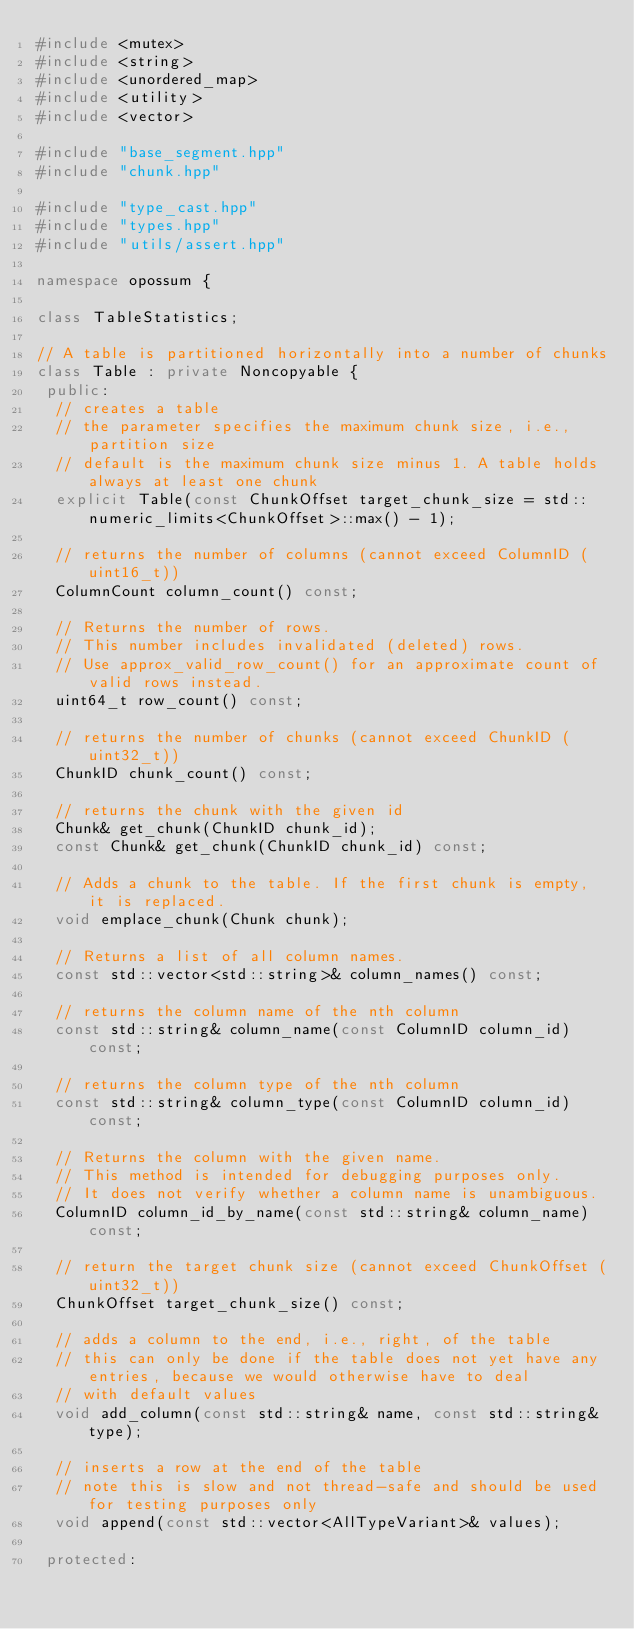Convert code to text. <code><loc_0><loc_0><loc_500><loc_500><_C++_>#include <mutex>
#include <string>
#include <unordered_map>
#include <utility>
#include <vector>

#include "base_segment.hpp"
#include "chunk.hpp"

#include "type_cast.hpp"
#include "types.hpp"
#include "utils/assert.hpp"

namespace opossum {

class TableStatistics;

// A table is partitioned horizontally into a number of chunks
class Table : private Noncopyable {
 public:
  // creates a table
  // the parameter specifies the maximum chunk size, i.e., partition size
  // default is the maximum chunk size minus 1. A table holds always at least one chunk
  explicit Table(const ChunkOffset target_chunk_size = std::numeric_limits<ChunkOffset>::max() - 1);

  // returns the number of columns (cannot exceed ColumnID (uint16_t))
  ColumnCount column_count() const;

  // Returns the number of rows.
  // This number includes invalidated (deleted) rows.
  // Use approx_valid_row_count() for an approximate count of valid rows instead.
  uint64_t row_count() const;

  // returns the number of chunks (cannot exceed ChunkID (uint32_t))
  ChunkID chunk_count() const;

  // returns the chunk with the given id
  Chunk& get_chunk(ChunkID chunk_id);
  const Chunk& get_chunk(ChunkID chunk_id) const;

  // Adds a chunk to the table. If the first chunk is empty, it is replaced.
  void emplace_chunk(Chunk chunk);

  // Returns a list of all column names.
  const std::vector<std::string>& column_names() const;

  // returns the column name of the nth column
  const std::string& column_name(const ColumnID column_id) const;

  // returns the column type of the nth column
  const std::string& column_type(const ColumnID column_id) const;

  // Returns the column with the given name.
  // This method is intended for debugging purposes only.
  // It does not verify whether a column name is unambiguous.
  ColumnID column_id_by_name(const std::string& column_name) const;

  // return the target chunk size (cannot exceed ChunkOffset (uint32_t))
  ChunkOffset target_chunk_size() const;

  // adds a column to the end, i.e., right, of the table
  // this can only be done if the table does not yet have any entries, because we would otherwise have to deal
  // with default values
  void add_column(const std::string& name, const std::string& type);

  // inserts a row at the end of the table
  // note this is slow and not thread-safe and should be used for testing purposes only
  void append(const std::vector<AllTypeVariant>& values);

 protected:</code> 